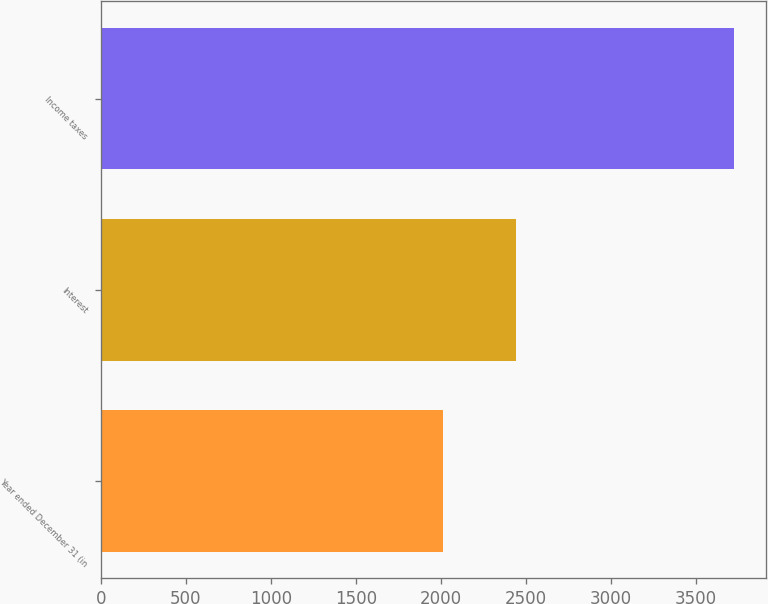Convert chart to OTSL. <chart><loc_0><loc_0><loc_500><loc_500><bar_chart><fcel>Year ended December 31 (in<fcel>Interest<fcel>Income taxes<nl><fcel>2015<fcel>2443<fcel>3726<nl></chart> 